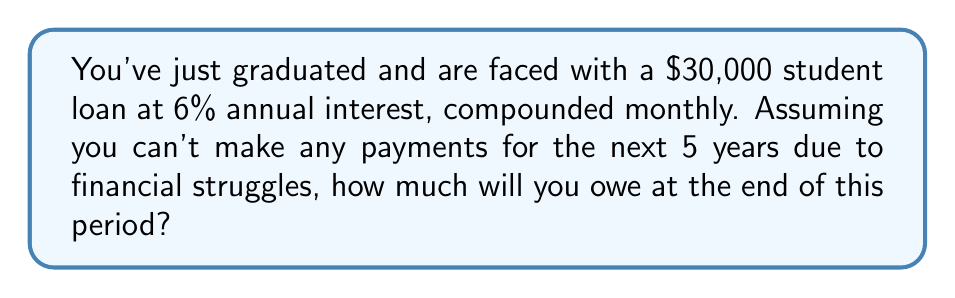Give your solution to this math problem. Let's approach this step-by-step:

1) The formula for compound interest is:
   $$A = P(1 + \frac{r}{n})^{nt}$$
   Where:
   $A$ = final amount
   $P$ = principal (initial loan amount)
   $r$ = annual interest rate (as a decimal)
   $n$ = number of times interest is compounded per year
   $t$ = number of years

2) Given information:
   $P = 30000$
   $r = 0.06$ (6% as a decimal)
   $n = 12$ (compounded monthly)
   $t = 5$ years

3) Plugging these values into the formula:
   $$A = 30000(1 + \frac{0.06}{12})^{12 \cdot 5}$$

4) Simplify inside the parentheses:
   $$A = 30000(1 + 0.005)^{60}$$

5) Calculate the exponent:
   $$A = 30000(1.005)^{60}$$

6) Use a calculator to compute this value:
   $$A = 30000 \cdot 1.3489815$$
   $$A = 40469.45$$

Therefore, after 5 years, you will owe $40,469.45.
Answer: $40,469.45 